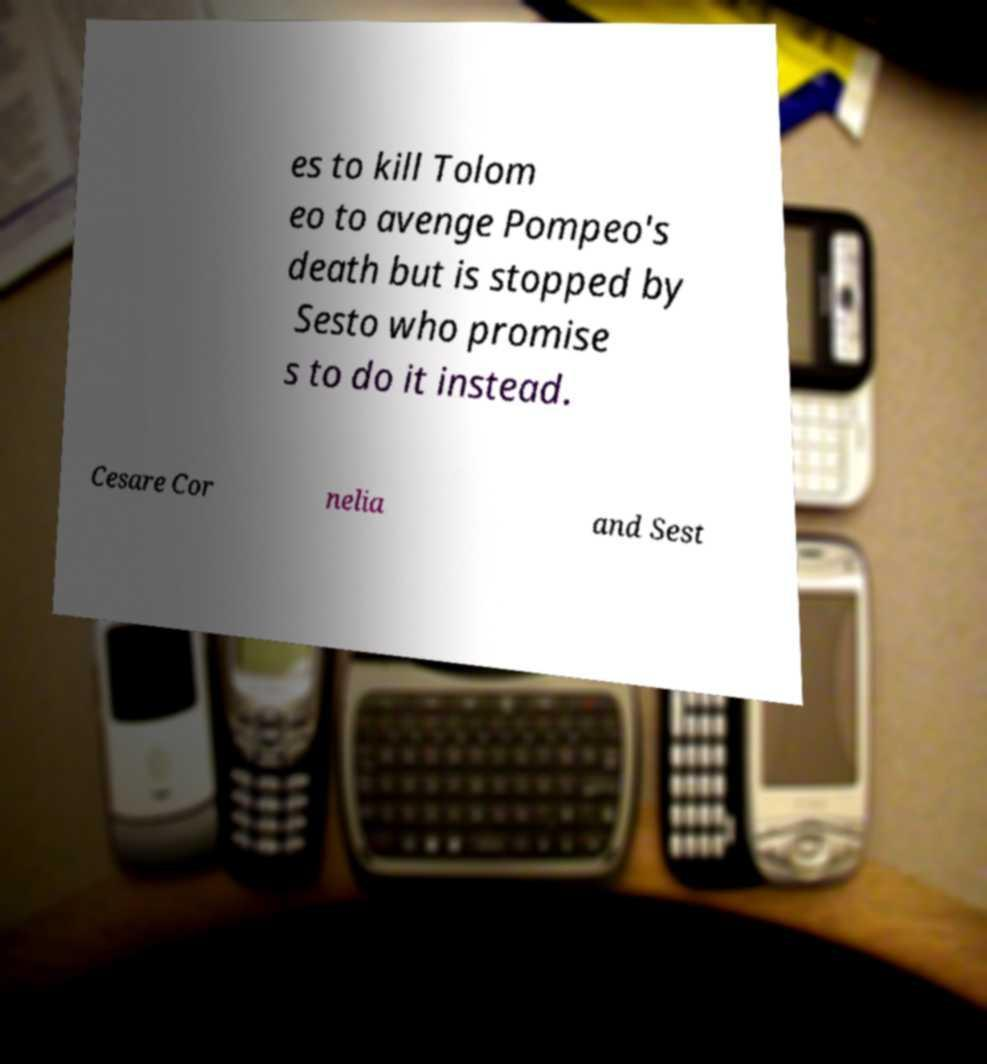Can you accurately transcribe the text from the provided image for me? es to kill Tolom eo to avenge Pompeo's death but is stopped by Sesto who promise s to do it instead. Cesare Cor nelia and Sest 